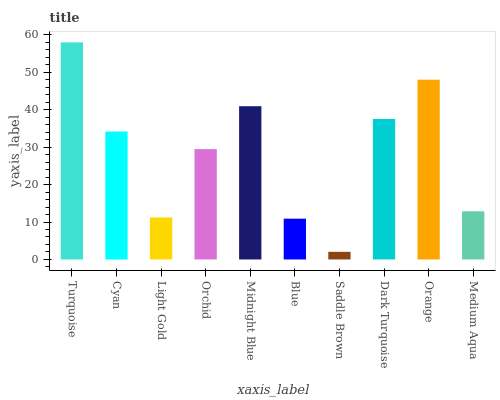Is Cyan the minimum?
Answer yes or no. No. Is Cyan the maximum?
Answer yes or no. No. Is Turquoise greater than Cyan?
Answer yes or no. Yes. Is Cyan less than Turquoise?
Answer yes or no. Yes. Is Cyan greater than Turquoise?
Answer yes or no. No. Is Turquoise less than Cyan?
Answer yes or no. No. Is Cyan the high median?
Answer yes or no. Yes. Is Orchid the low median?
Answer yes or no. Yes. Is Orchid the high median?
Answer yes or no. No. Is Blue the low median?
Answer yes or no. No. 